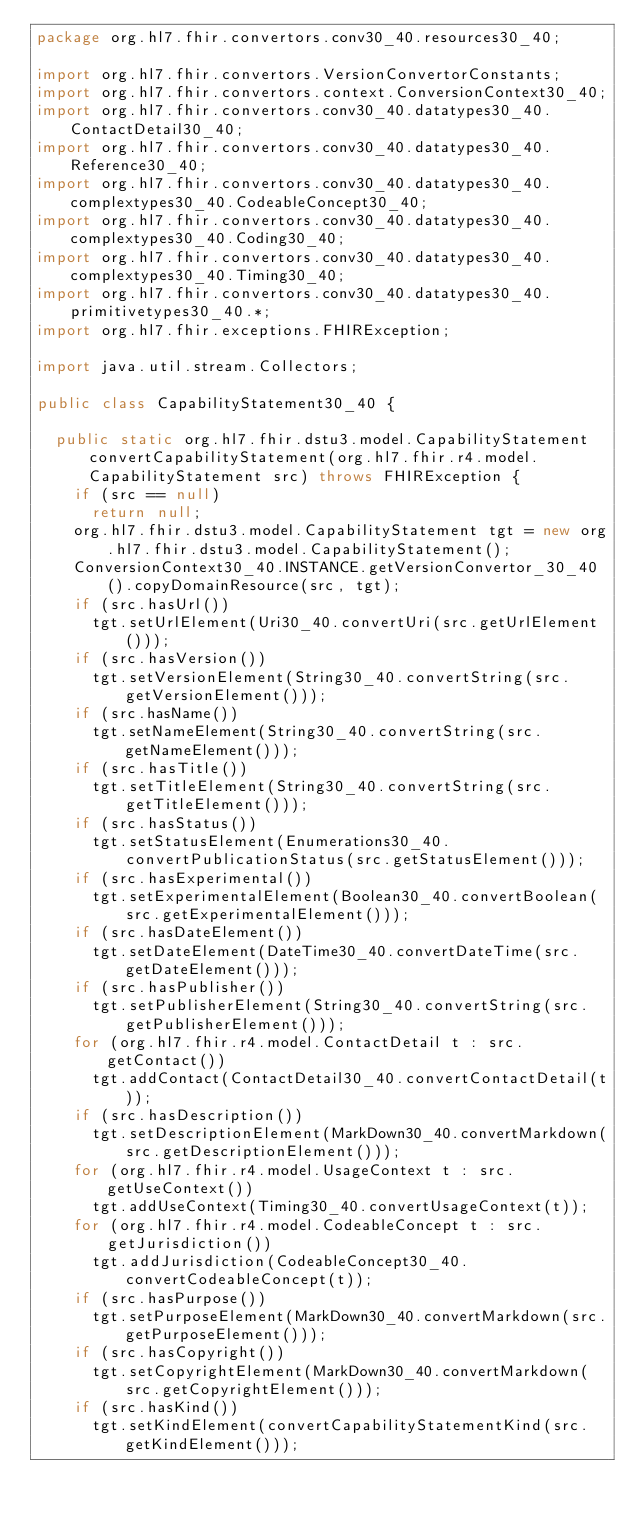<code> <loc_0><loc_0><loc_500><loc_500><_Java_>package org.hl7.fhir.convertors.conv30_40.resources30_40;

import org.hl7.fhir.convertors.VersionConvertorConstants;
import org.hl7.fhir.convertors.context.ConversionContext30_40;
import org.hl7.fhir.convertors.conv30_40.datatypes30_40.ContactDetail30_40;
import org.hl7.fhir.convertors.conv30_40.datatypes30_40.Reference30_40;
import org.hl7.fhir.convertors.conv30_40.datatypes30_40.complextypes30_40.CodeableConcept30_40;
import org.hl7.fhir.convertors.conv30_40.datatypes30_40.complextypes30_40.Coding30_40;
import org.hl7.fhir.convertors.conv30_40.datatypes30_40.complextypes30_40.Timing30_40;
import org.hl7.fhir.convertors.conv30_40.datatypes30_40.primitivetypes30_40.*;
import org.hl7.fhir.exceptions.FHIRException;

import java.util.stream.Collectors;

public class CapabilityStatement30_40 {

  public static org.hl7.fhir.dstu3.model.CapabilityStatement convertCapabilityStatement(org.hl7.fhir.r4.model.CapabilityStatement src) throws FHIRException {
    if (src == null)
      return null;
    org.hl7.fhir.dstu3.model.CapabilityStatement tgt = new org.hl7.fhir.dstu3.model.CapabilityStatement();
    ConversionContext30_40.INSTANCE.getVersionConvertor_30_40().copyDomainResource(src, tgt);
    if (src.hasUrl())
      tgt.setUrlElement(Uri30_40.convertUri(src.getUrlElement()));
    if (src.hasVersion())
      tgt.setVersionElement(String30_40.convertString(src.getVersionElement()));
    if (src.hasName())
      tgt.setNameElement(String30_40.convertString(src.getNameElement()));
    if (src.hasTitle())
      tgt.setTitleElement(String30_40.convertString(src.getTitleElement()));
    if (src.hasStatus())
      tgt.setStatusElement(Enumerations30_40.convertPublicationStatus(src.getStatusElement()));
    if (src.hasExperimental())
      tgt.setExperimentalElement(Boolean30_40.convertBoolean(src.getExperimentalElement()));
    if (src.hasDateElement())
      tgt.setDateElement(DateTime30_40.convertDateTime(src.getDateElement()));
    if (src.hasPublisher())
      tgt.setPublisherElement(String30_40.convertString(src.getPublisherElement()));
    for (org.hl7.fhir.r4.model.ContactDetail t : src.getContact())
      tgt.addContact(ContactDetail30_40.convertContactDetail(t));
    if (src.hasDescription())
      tgt.setDescriptionElement(MarkDown30_40.convertMarkdown(src.getDescriptionElement()));
    for (org.hl7.fhir.r4.model.UsageContext t : src.getUseContext())
      tgt.addUseContext(Timing30_40.convertUsageContext(t));
    for (org.hl7.fhir.r4.model.CodeableConcept t : src.getJurisdiction())
      tgt.addJurisdiction(CodeableConcept30_40.convertCodeableConcept(t));
    if (src.hasPurpose())
      tgt.setPurposeElement(MarkDown30_40.convertMarkdown(src.getPurposeElement()));
    if (src.hasCopyright())
      tgt.setCopyrightElement(MarkDown30_40.convertMarkdown(src.getCopyrightElement()));
    if (src.hasKind())
      tgt.setKindElement(convertCapabilityStatementKind(src.getKindElement()));</code> 